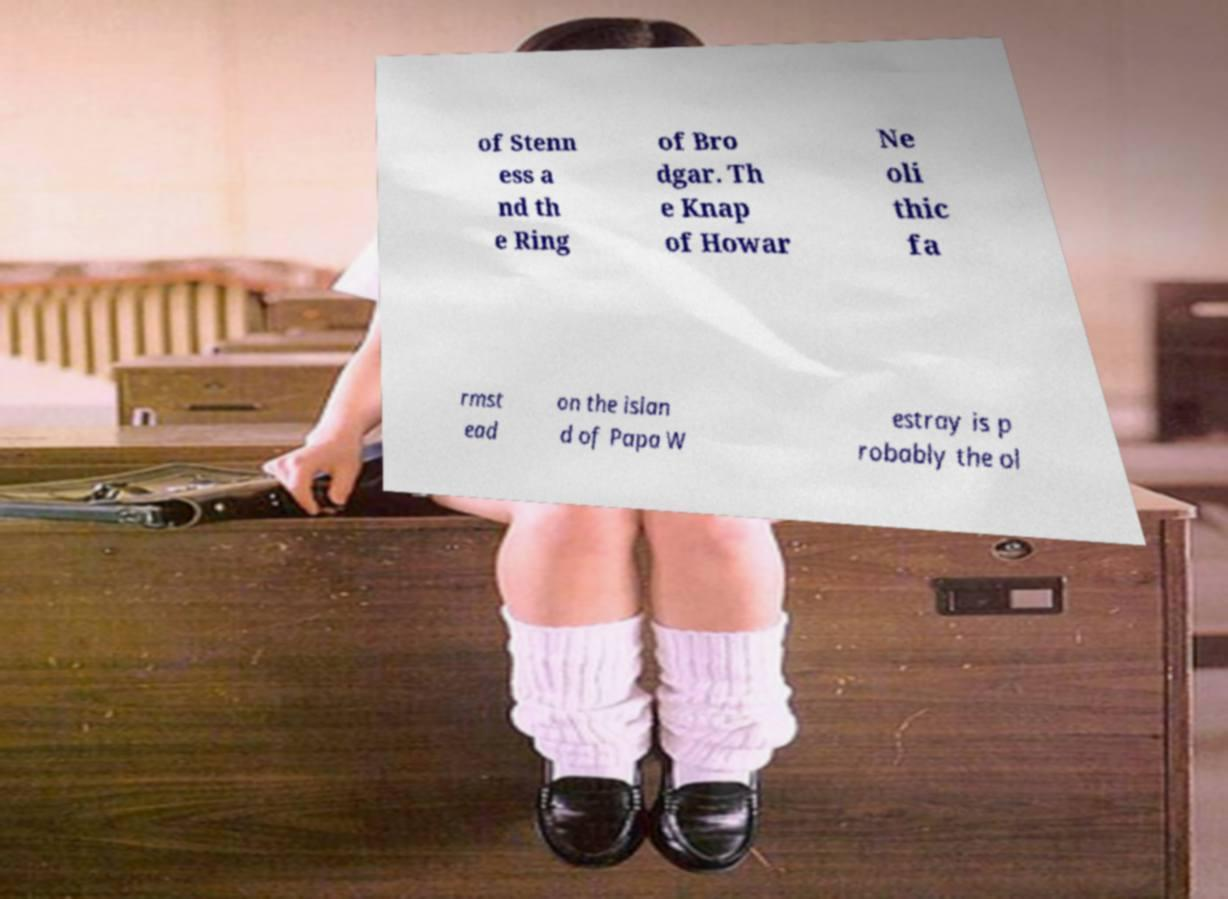Can you accurately transcribe the text from the provided image for me? of Stenn ess a nd th e Ring of Bro dgar. Th e Knap of Howar Ne oli thic fa rmst ead on the islan d of Papa W estray is p robably the ol 